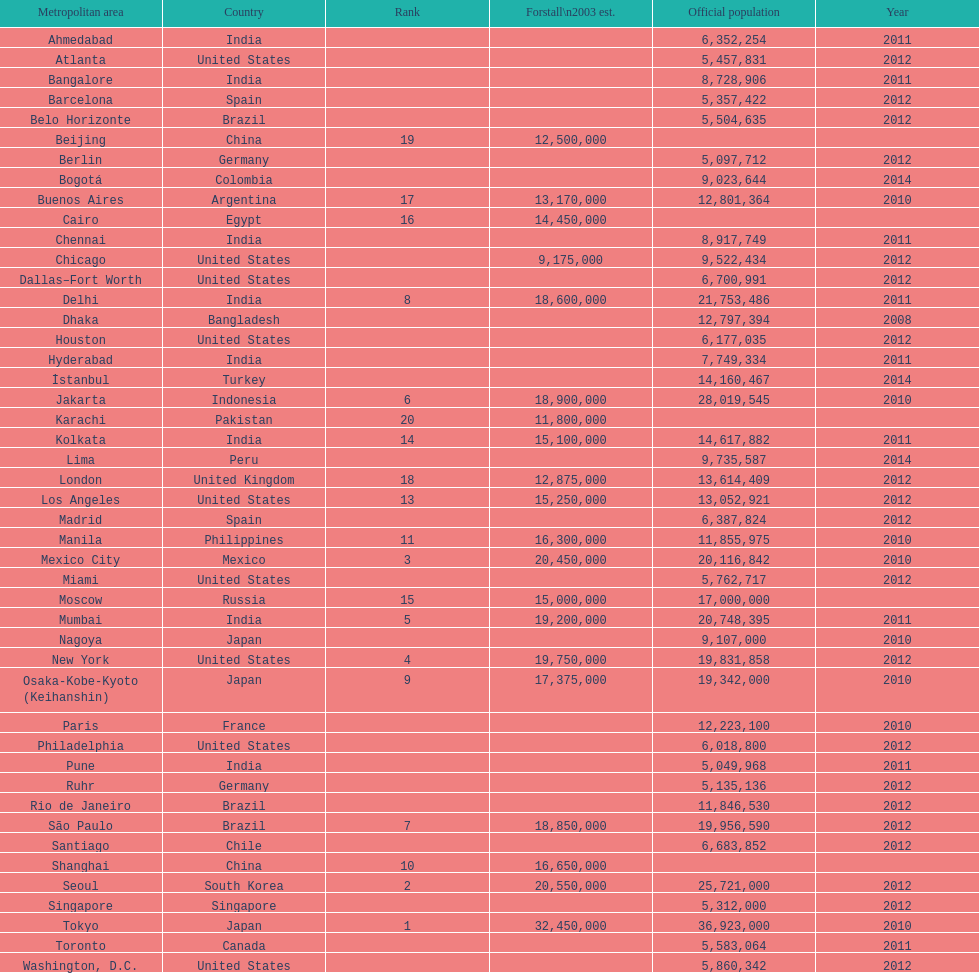Mention a city belonging to the same territory as bangalore. Ahmedabad. 